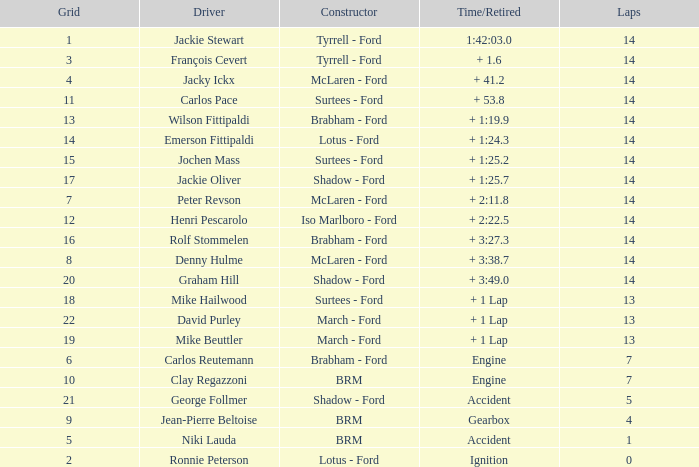What grad has a Time/Retired of + 1:24.3? 14.0. 